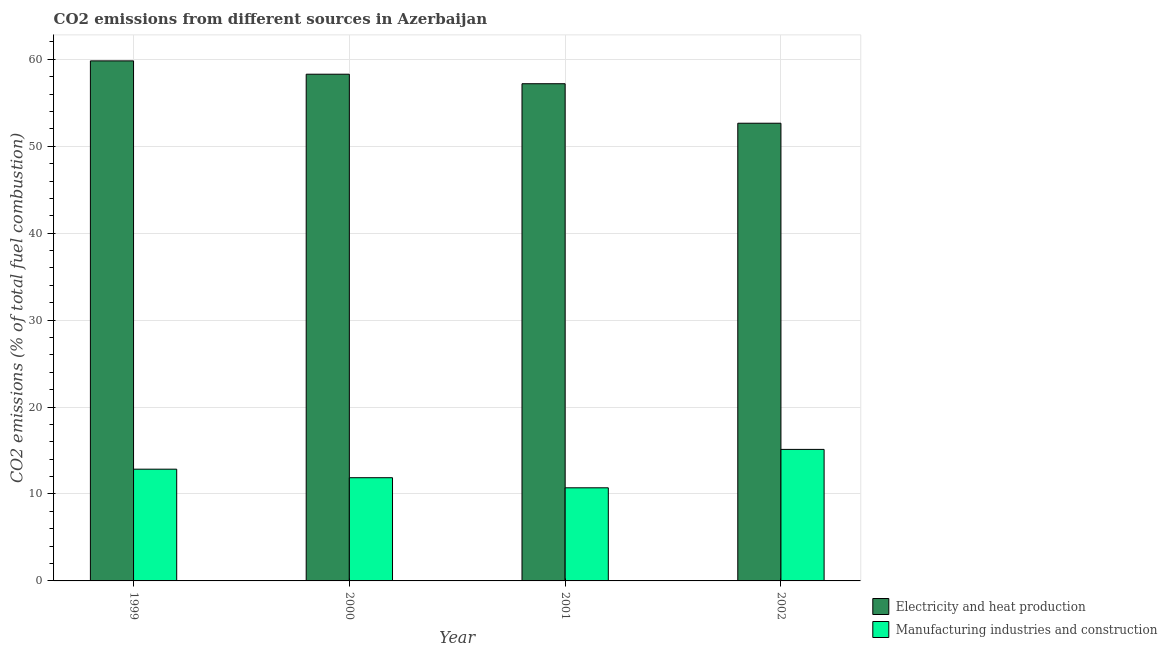How many different coloured bars are there?
Offer a terse response. 2. How many groups of bars are there?
Give a very brief answer. 4. Are the number of bars per tick equal to the number of legend labels?
Keep it short and to the point. Yes. Are the number of bars on each tick of the X-axis equal?
Your answer should be compact. Yes. How many bars are there on the 1st tick from the left?
Offer a terse response. 2. What is the co2 emissions due to electricity and heat production in 2002?
Give a very brief answer. 52.65. Across all years, what is the maximum co2 emissions due to electricity and heat production?
Your response must be concise. 59.82. Across all years, what is the minimum co2 emissions due to electricity and heat production?
Give a very brief answer. 52.65. In which year was the co2 emissions due to electricity and heat production minimum?
Provide a succinct answer. 2002. What is the total co2 emissions due to electricity and heat production in the graph?
Give a very brief answer. 227.94. What is the difference between the co2 emissions due to electricity and heat production in 2001 and that in 2002?
Keep it short and to the point. 4.54. What is the difference between the co2 emissions due to electricity and heat production in 1999 and the co2 emissions due to manufacturing industries in 2002?
Offer a terse response. 7.17. What is the average co2 emissions due to electricity and heat production per year?
Your response must be concise. 56.99. What is the ratio of the co2 emissions due to electricity and heat production in 1999 to that in 2002?
Your answer should be very brief. 1.14. What is the difference between the highest and the second highest co2 emissions due to manufacturing industries?
Keep it short and to the point. 2.28. What is the difference between the highest and the lowest co2 emissions due to manufacturing industries?
Your answer should be compact. 4.42. Is the sum of the co2 emissions due to manufacturing industries in 1999 and 2001 greater than the maximum co2 emissions due to electricity and heat production across all years?
Keep it short and to the point. Yes. What does the 1st bar from the left in 2000 represents?
Ensure brevity in your answer.  Electricity and heat production. What does the 2nd bar from the right in 1999 represents?
Ensure brevity in your answer.  Electricity and heat production. Are all the bars in the graph horizontal?
Your response must be concise. No. How many years are there in the graph?
Your answer should be compact. 4. What is the difference between two consecutive major ticks on the Y-axis?
Your answer should be very brief. 10. Are the values on the major ticks of Y-axis written in scientific E-notation?
Offer a terse response. No. Does the graph contain grids?
Keep it short and to the point. Yes. How are the legend labels stacked?
Provide a short and direct response. Vertical. What is the title of the graph?
Give a very brief answer. CO2 emissions from different sources in Azerbaijan. Does "Depositors" appear as one of the legend labels in the graph?
Provide a short and direct response. No. What is the label or title of the Y-axis?
Offer a very short reply. CO2 emissions (% of total fuel combustion). What is the CO2 emissions (% of total fuel combustion) of Electricity and heat production in 1999?
Provide a short and direct response. 59.82. What is the CO2 emissions (% of total fuel combustion) in Manufacturing industries and construction in 1999?
Your response must be concise. 12.85. What is the CO2 emissions (% of total fuel combustion) of Electricity and heat production in 2000?
Provide a succinct answer. 58.29. What is the CO2 emissions (% of total fuel combustion) of Manufacturing industries and construction in 2000?
Provide a short and direct response. 11.87. What is the CO2 emissions (% of total fuel combustion) of Electricity and heat production in 2001?
Provide a short and direct response. 57.19. What is the CO2 emissions (% of total fuel combustion) in Manufacturing industries and construction in 2001?
Your answer should be compact. 10.71. What is the CO2 emissions (% of total fuel combustion) in Electricity and heat production in 2002?
Ensure brevity in your answer.  52.65. What is the CO2 emissions (% of total fuel combustion) in Manufacturing industries and construction in 2002?
Your answer should be very brief. 15.13. Across all years, what is the maximum CO2 emissions (% of total fuel combustion) of Electricity and heat production?
Keep it short and to the point. 59.82. Across all years, what is the maximum CO2 emissions (% of total fuel combustion) of Manufacturing industries and construction?
Keep it short and to the point. 15.13. Across all years, what is the minimum CO2 emissions (% of total fuel combustion) in Electricity and heat production?
Your answer should be very brief. 52.65. Across all years, what is the minimum CO2 emissions (% of total fuel combustion) of Manufacturing industries and construction?
Your answer should be compact. 10.71. What is the total CO2 emissions (% of total fuel combustion) of Electricity and heat production in the graph?
Ensure brevity in your answer.  227.94. What is the total CO2 emissions (% of total fuel combustion) of Manufacturing industries and construction in the graph?
Make the answer very short. 50.57. What is the difference between the CO2 emissions (% of total fuel combustion) in Electricity and heat production in 1999 and that in 2000?
Offer a terse response. 1.53. What is the difference between the CO2 emissions (% of total fuel combustion) of Manufacturing industries and construction in 1999 and that in 2000?
Ensure brevity in your answer.  0.98. What is the difference between the CO2 emissions (% of total fuel combustion) in Electricity and heat production in 1999 and that in 2001?
Provide a succinct answer. 2.63. What is the difference between the CO2 emissions (% of total fuel combustion) in Manufacturing industries and construction in 1999 and that in 2001?
Provide a succinct answer. 2.14. What is the difference between the CO2 emissions (% of total fuel combustion) of Electricity and heat production in 1999 and that in 2002?
Offer a terse response. 7.17. What is the difference between the CO2 emissions (% of total fuel combustion) of Manufacturing industries and construction in 1999 and that in 2002?
Provide a short and direct response. -2.28. What is the difference between the CO2 emissions (% of total fuel combustion) of Electricity and heat production in 2000 and that in 2001?
Your answer should be very brief. 1.09. What is the difference between the CO2 emissions (% of total fuel combustion) in Manufacturing industries and construction in 2000 and that in 2001?
Keep it short and to the point. 1.16. What is the difference between the CO2 emissions (% of total fuel combustion) in Electricity and heat production in 2000 and that in 2002?
Offer a terse response. 5.64. What is the difference between the CO2 emissions (% of total fuel combustion) in Manufacturing industries and construction in 2000 and that in 2002?
Keep it short and to the point. -3.26. What is the difference between the CO2 emissions (% of total fuel combustion) in Electricity and heat production in 2001 and that in 2002?
Provide a short and direct response. 4.54. What is the difference between the CO2 emissions (% of total fuel combustion) of Manufacturing industries and construction in 2001 and that in 2002?
Offer a terse response. -4.42. What is the difference between the CO2 emissions (% of total fuel combustion) of Electricity and heat production in 1999 and the CO2 emissions (% of total fuel combustion) of Manufacturing industries and construction in 2000?
Your answer should be very brief. 47.95. What is the difference between the CO2 emissions (% of total fuel combustion) of Electricity and heat production in 1999 and the CO2 emissions (% of total fuel combustion) of Manufacturing industries and construction in 2001?
Provide a succinct answer. 49.11. What is the difference between the CO2 emissions (% of total fuel combustion) of Electricity and heat production in 1999 and the CO2 emissions (% of total fuel combustion) of Manufacturing industries and construction in 2002?
Keep it short and to the point. 44.69. What is the difference between the CO2 emissions (% of total fuel combustion) in Electricity and heat production in 2000 and the CO2 emissions (% of total fuel combustion) in Manufacturing industries and construction in 2001?
Keep it short and to the point. 47.57. What is the difference between the CO2 emissions (% of total fuel combustion) of Electricity and heat production in 2000 and the CO2 emissions (% of total fuel combustion) of Manufacturing industries and construction in 2002?
Ensure brevity in your answer.  43.16. What is the difference between the CO2 emissions (% of total fuel combustion) of Electricity and heat production in 2001 and the CO2 emissions (% of total fuel combustion) of Manufacturing industries and construction in 2002?
Make the answer very short. 42.06. What is the average CO2 emissions (% of total fuel combustion) in Electricity and heat production per year?
Make the answer very short. 56.99. What is the average CO2 emissions (% of total fuel combustion) in Manufacturing industries and construction per year?
Ensure brevity in your answer.  12.64. In the year 1999, what is the difference between the CO2 emissions (% of total fuel combustion) in Electricity and heat production and CO2 emissions (% of total fuel combustion) in Manufacturing industries and construction?
Offer a very short reply. 46.97. In the year 2000, what is the difference between the CO2 emissions (% of total fuel combustion) in Electricity and heat production and CO2 emissions (% of total fuel combustion) in Manufacturing industries and construction?
Keep it short and to the point. 46.41. In the year 2001, what is the difference between the CO2 emissions (% of total fuel combustion) of Electricity and heat production and CO2 emissions (% of total fuel combustion) of Manufacturing industries and construction?
Keep it short and to the point. 46.48. In the year 2002, what is the difference between the CO2 emissions (% of total fuel combustion) in Electricity and heat production and CO2 emissions (% of total fuel combustion) in Manufacturing industries and construction?
Your response must be concise. 37.52. What is the ratio of the CO2 emissions (% of total fuel combustion) of Electricity and heat production in 1999 to that in 2000?
Offer a very short reply. 1.03. What is the ratio of the CO2 emissions (% of total fuel combustion) of Manufacturing industries and construction in 1999 to that in 2000?
Your answer should be very brief. 1.08. What is the ratio of the CO2 emissions (% of total fuel combustion) in Electricity and heat production in 1999 to that in 2001?
Provide a short and direct response. 1.05. What is the ratio of the CO2 emissions (% of total fuel combustion) of Electricity and heat production in 1999 to that in 2002?
Your response must be concise. 1.14. What is the ratio of the CO2 emissions (% of total fuel combustion) of Manufacturing industries and construction in 1999 to that in 2002?
Provide a succinct answer. 0.85. What is the ratio of the CO2 emissions (% of total fuel combustion) in Electricity and heat production in 2000 to that in 2001?
Your answer should be very brief. 1.02. What is the ratio of the CO2 emissions (% of total fuel combustion) of Manufacturing industries and construction in 2000 to that in 2001?
Your response must be concise. 1.11. What is the ratio of the CO2 emissions (% of total fuel combustion) of Electricity and heat production in 2000 to that in 2002?
Ensure brevity in your answer.  1.11. What is the ratio of the CO2 emissions (% of total fuel combustion) in Manufacturing industries and construction in 2000 to that in 2002?
Provide a short and direct response. 0.78. What is the ratio of the CO2 emissions (% of total fuel combustion) of Electricity and heat production in 2001 to that in 2002?
Your answer should be very brief. 1.09. What is the ratio of the CO2 emissions (% of total fuel combustion) in Manufacturing industries and construction in 2001 to that in 2002?
Offer a terse response. 0.71. What is the difference between the highest and the second highest CO2 emissions (% of total fuel combustion) of Electricity and heat production?
Provide a short and direct response. 1.53. What is the difference between the highest and the second highest CO2 emissions (% of total fuel combustion) in Manufacturing industries and construction?
Ensure brevity in your answer.  2.28. What is the difference between the highest and the lowest CO2 emissions (% of total fuel combustion) of Electricity and heat production?
Ensure brevity in your answer.  7.17. What is the difference between the highest and the lowest CO2 emissions (% of total fuel combustion) of Manufacturing industries and construction?
Provide a short and direct response. 4.42. 